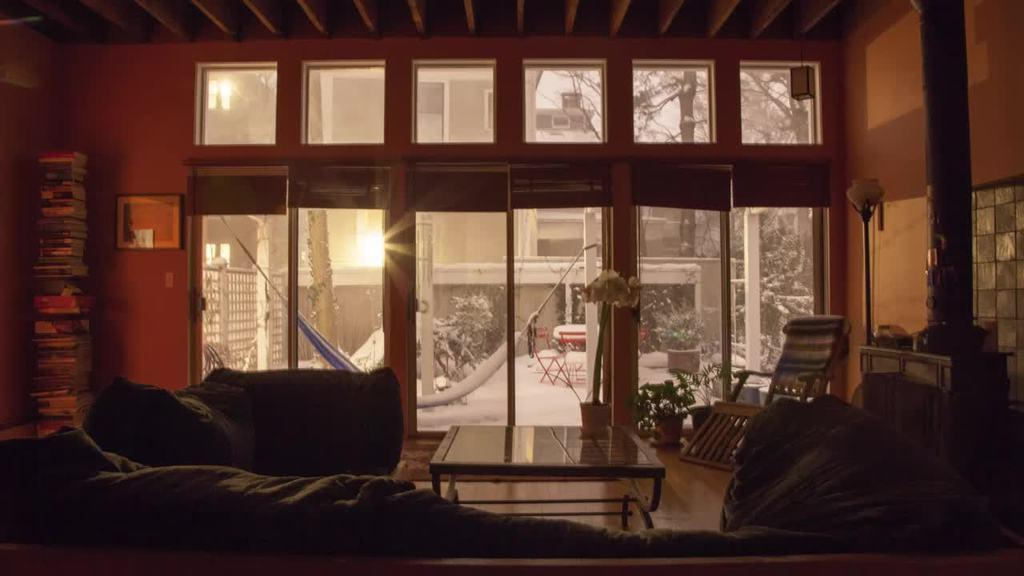What type of furniture is present in the image? There is a couch in the image. What other piece of furniture can be seen in the image? There is a table in the image. What items are related to reading or learning in the image? There are books in the image. What type of structure is depicted in the image? There is a house in the image. What architectural feature is present in the image? There is a glass door in the image. What type of living organisms can be seen in the image? There are plants in the image. What type of natural environment is visible in the image? There are trees in the image. Can you tell me which vegetables are growing in the image? There are no vegetables present in the image; it features plants and trees. How many girls can be seen playing with a doll in the image? There are no girls or dolls present in the image. 